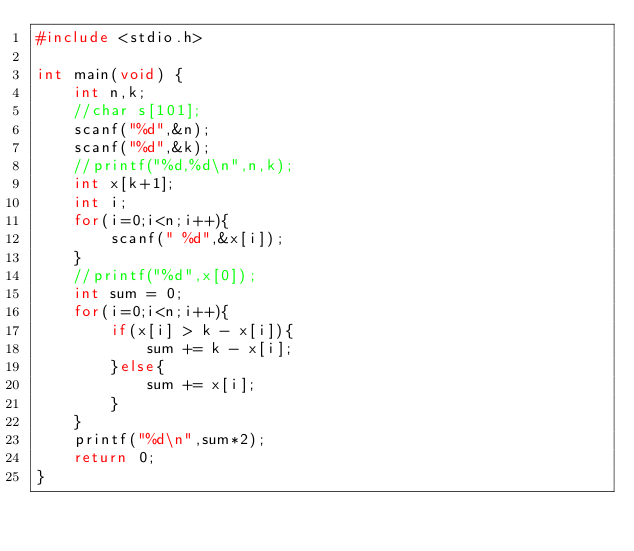<code> <loc_0><loc_0><loc_500><loc_500><_C_>#include <stdio.h>

int main(void) {
    int n,k;
    //char s[101];
    scanf("%d",&n);
    scanf("%d",&k);
    //printf("%d,%d\n",n,k);
    int x[k+1];
    int i;
    for(i=0;i<n;i++){
        scanf(" %d",&x[i]);
    }
    //printf("%d",x[0]);
    int sum = 0;
    for(i=0;i<n;i++){
        if(x[i] > k - x[i]){
            sum += k - x[i];
        }else{
            sum += x[i];
        }
    }
    printf("%d\n",sum*2);
    return 0;
}
</code> 